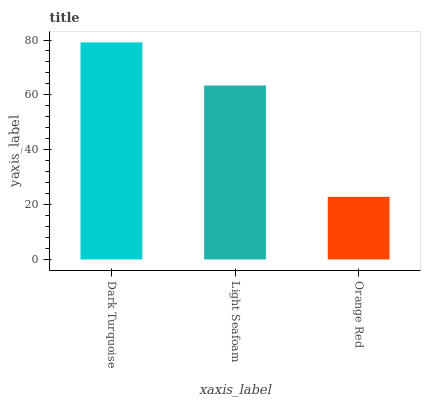Is Orange Red the minimum?
Answer yes or no. Yes. Is Dark Turquoise the maximum?
Answer yes or no. Yes. Is Light Seafoam the minimum?
Answer yes or no. No. Is Light Seafoam the maximum?
Answer yes or no. No. Is Dark Turquoise greater than Light Seafoam?
Answer yes or no. Yes. Is Light Seafoam less than Dark Turquoise?
Answer yes or no. Yes. Is Light Seafoam greater than Dark Turquoise?
Answer yes or no. No. Is Dark Turquoise less than Light Seafoam?
Answer yes or no. No. Is Light Seafoam the high median?
Answer yes or no. Yes. Is Light Seafoam the low median?
Answer yes or no. Yes. Is Dark Turquoise the high median?
Answer yes or no. No. Is Orange Red the low median?
Answer yes or no. No. 